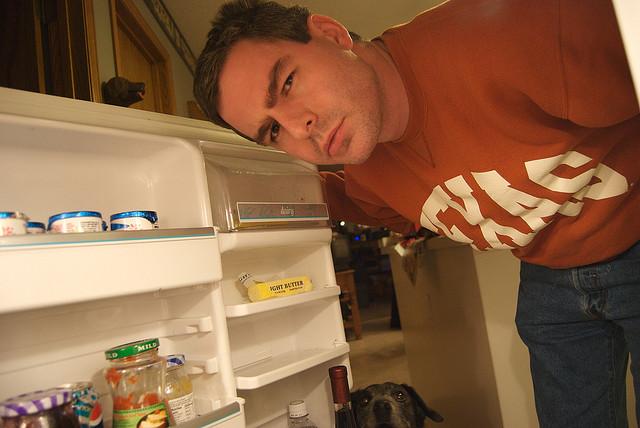Is the man smiling?
Short answer required. No. Could the man burn himself?
Give a very brief answer. No. What's in this fridge?
Concise answer only. Food. What state is on the man's shirt?
Be succinct. Texas. Is this person an adult?
Short answer required. Yes. 